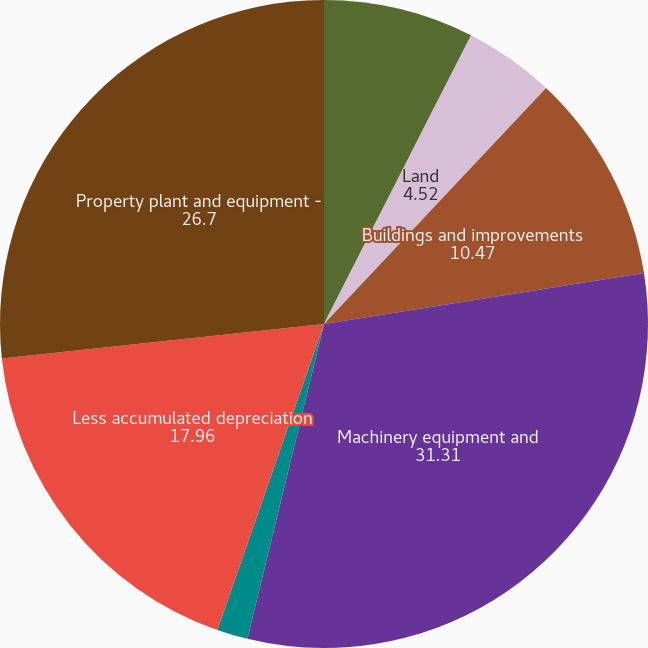<chart> <loc_0><loc_0><loc_500><loc_500><pie_chart><fcel>December 31<fcel>Land<fcel>Buildings and improvements<fcel>Machinery equipment and<fcel>Construction in progress<fcel>Less accumulated depreciation<fcel>Property plant and equipment -<nl><fcel>7.5%<fcel>4.52%<fcel>10.47%<fcel>31.31%<fcel>1.54%<fcel>17.96%<fcel>26.7%<nl></chart> 